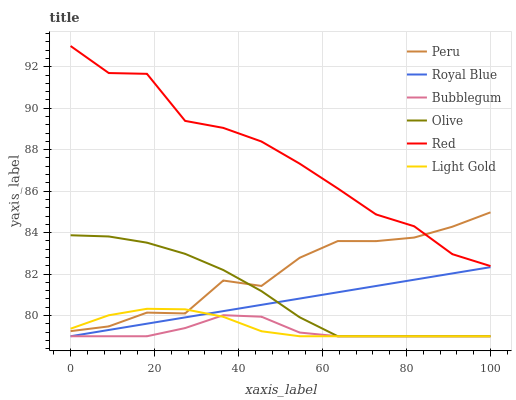Does Bubblegum have the minimum area under the curve?
Answer yes or no. Yes. Does Red have the maximum area under the curve?
Answer yes or no. Yes. Does Royal Blue have the minimum area under the curve?
Answer yes or no. No. Does Royal Blue have the maximum area under the curve?
Answer yes or no. No. Is Royal Blue the smoothest?
Answer yes or no. Yes. Is Red the roughest?
Answer yes or no. Yes. Is Peru the smoothest?
Answer yes or no. No. Is Peru the roughest?
Answer yes or no. No. Does Bubblegum have the lowest value?
Answer yes or no. Yes. Does Peru have the lowest value?
Answer yes or no. No. Does Red have the highest value?
Answer yes or no. Yes. Does Royal Blue have the highest value?
Answer yes or no. No. Is Bubblegum less than Red?
Answer yes or no. Yes. Is Red greater than Bubblegum?
Answer yes or no. Yes. Does Bubblegum intersect Royal Blue?
Answer yes or no. Yes. Is Bubblegum less than Royal Blue?
Answer yes or no. No. Is Bubblegum greater than Royal Blue?
Answer yes or no. No. Does Bubblegum intersect Red?
Answer yes or no. No. 